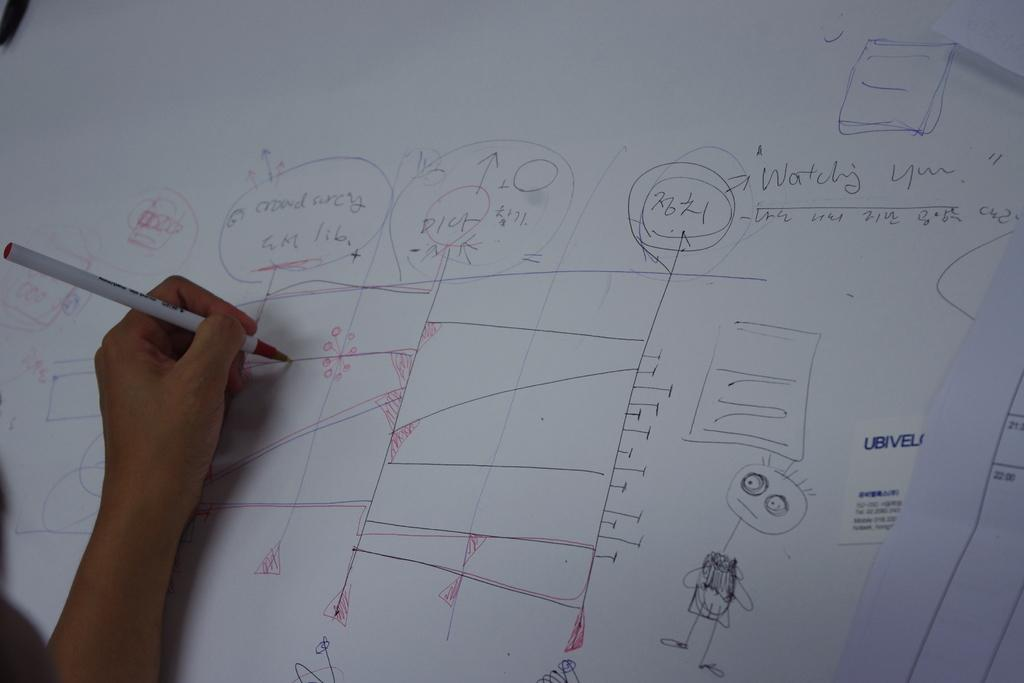<image>
Provide a brief description of the given image. a white board being written on has words Watching You already on it 